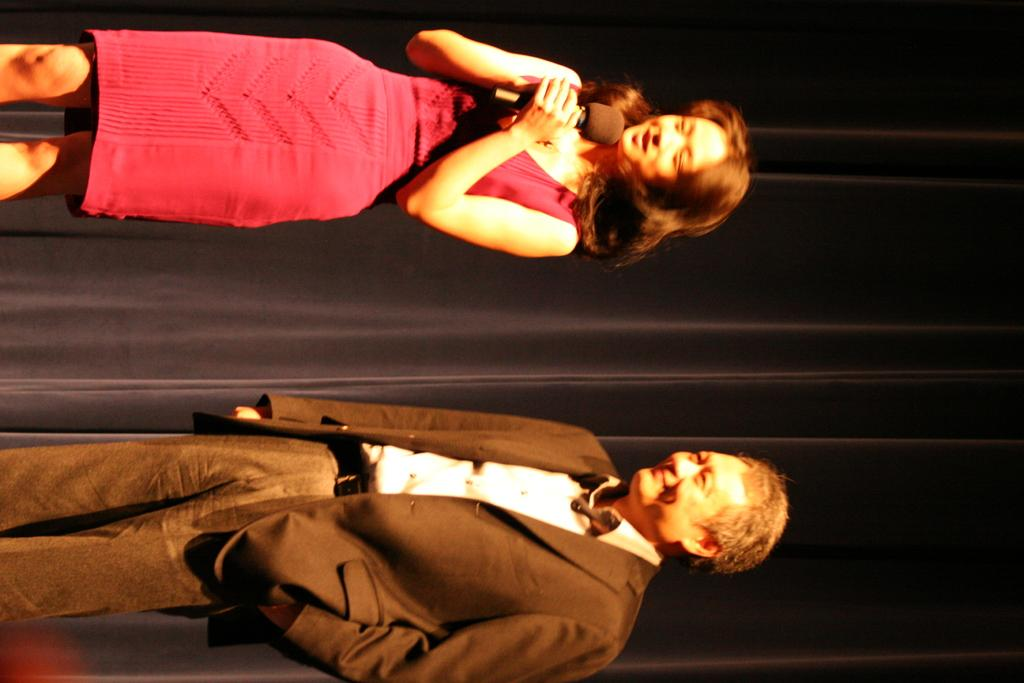How many people are in the image? There are two people standing in the image. What is the facial expression of the people in the image? Both people are smiling. Can you identify the gender of one of the people in the image? Yes, there is a woman among the two people. What is the woman holding in the image? The woman is holding a microphone. What can be seen in the background of the image? There is a curtain in the background of the image. What type of hat is the judge wearing in the image? There is no judge or hat present in the image. What is the boundary between the two people in the image? There is no boundary between the two people in the image; they are standing side by side. 